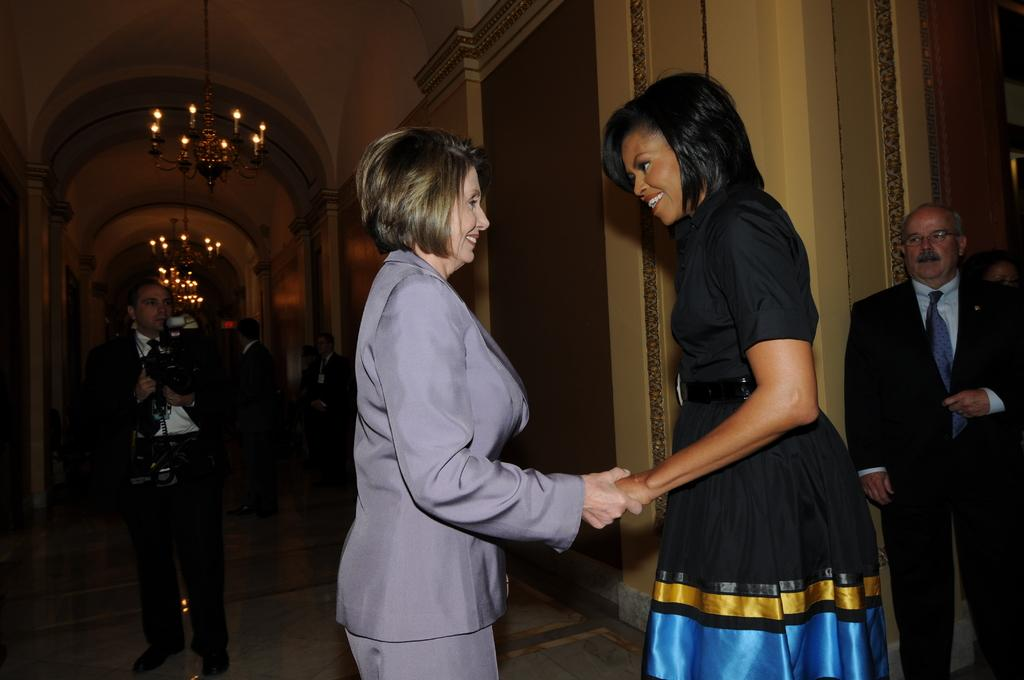What is the man in the image holding? The man is holding a camera. What can be seen in the middle of the image? There are two women standing in the middle of the image. Where is the other man located in the image? There is a man standing at the right side of the image. What type of lip can be seen on the canvas in the image? There is no lip or canvas present in the image. What position is the man holding the camera in the image? The position of the man holding the camera cannot be determined from the image alone, as it only shows him holding the camera without any indication of his posture or stance. 